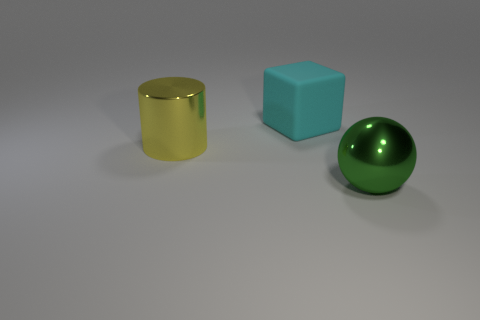There is a metallic thing that is behind the big metal object that is to the right of the large yellow cylinder; what shape is it?
Offer a terse response. Cylinder. There is a big matte thing behind the big yellow shiny cylinder; is it the same shape as the green shiny thing?
Offer a terse response. No. Are there more large cylinders to the left of the cyan thing than large green balls in front of the green ball?
Your response must be concise. Yes. There is a large metal thing right of the big cube; how many big metal objects are to the left of it?
Your response must be concise. 1. How many other objects are there of the same color as the big sphere?
Provide a short and direct response. 0. There is a big metal thing on the left side of the metallic thing right of the large cyan object; what color is it?
Provide a short and direct response. Yellow. Are there any cubes that have the same color as the big cylinder?
Offer a terse response. No. How many matte objects are either big cyan things or big purple cylinders?
Ensure brevity in your answer.  1. Are there any large blue cubes that have the same material as the yellow cylinder?
Provide a short and direct response. No. What number of objects are both in front of the big cyan matte cube and on the right side of the yellow metal cylinder?
Your response must be concise. 1. 